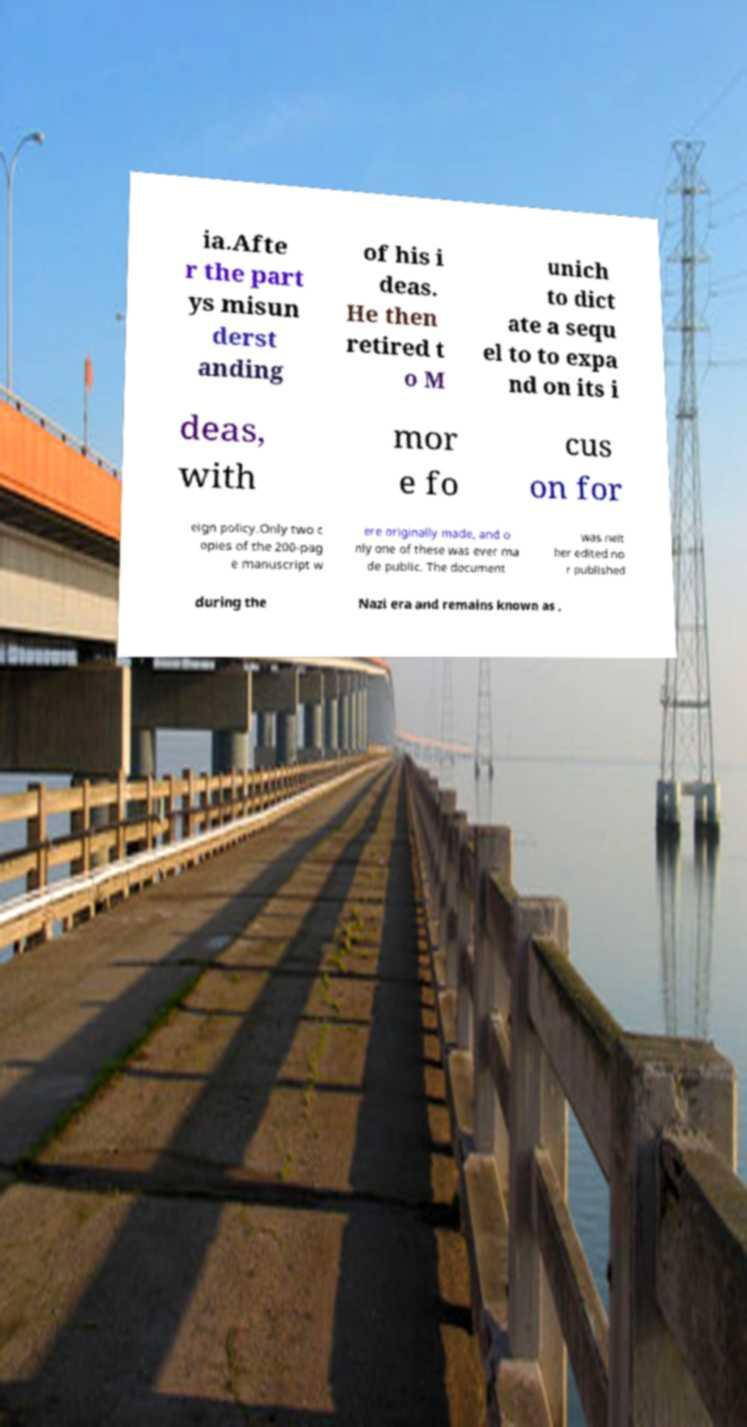There's text embedded in this image that I need extracted. Can you transcribe it verbatim? ia.Afte r the part ys misun derst anding of his i deas. He then retired t o M unich to dict ate a sequ el to to expa nd on its i deas, with mor e fo cus on for eign policy.Only two c opies of the 200-pag e manuscript w ere originally made, and o nly one of these was ever ma de public. The document was neit her edited no r published during the Nazi era and remains known as , 